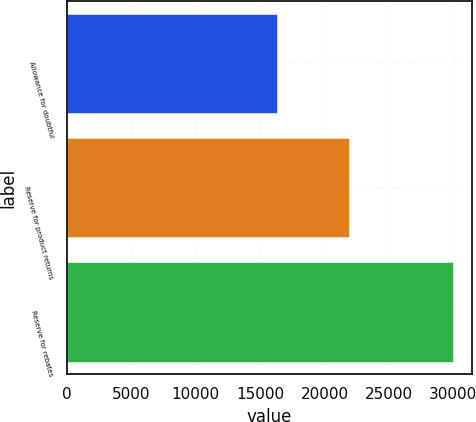Convert chart. <chart><loc_0><loc_0><loc_500><loc_500><bar_chart><fcel>Allowance for doubtful<fcel>Reserve for product returns<fcel>Reserve for rebates<nl><fcel>16285<fcel>21932<fcel>29952<nl></chart> 